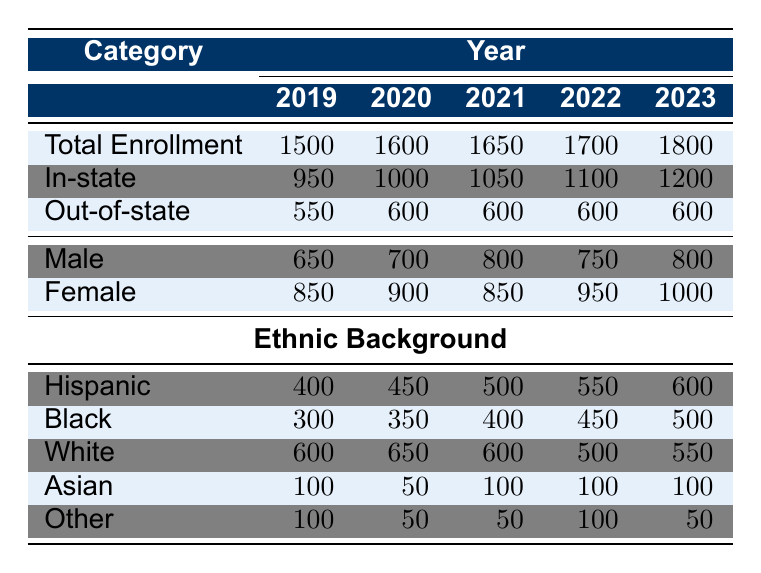What was the total enrollment of first-generation college students in 2022? The table shows that the total enrollment in 2022 is listed directly under the "Total Enrollment" row for that year, which is 1700.
Answer: 1700 How many in-state first-generation college students enrolled in 2021? The number of in-state students for 2021 is specified in the corresponding row for that year, which is 1050.
Answer: 1050 What percentage of first-generation college students in 2023 were out-of-state students? The total enrollment in 2023 is 1800, and the out-of-state students are 600. The percentage is calculated as (600/1800) * 100 = 33.33%.
Answer: 33.33% Which year had the highest total enrollment of first-generation college students? By reviewing the "Total Enrollment" row, 2023 has the highest number listed at 1800, indicating it is the year with the highest enrollment.
Answer: 2023 Were there more male or female first-generation students in 2020? In 2020, there were 700 male and 900 female students. Comparing these numbers, it's clear that there were more females.
Answer: Female What was the increase in total enrollment from 2019 to 2023? The total enrollment in 2019 was 1500 and in 2023 was 1800. The increase is calculated by subtracting 1500 from 1800, which equals 300.
Answer: 300 What is the average number of Hispanic first-generation students over the five years? The numbers for Hispanic students are 400 (2019), 450 (2020), 500 (2021), 550 (2022), and 600 (2023). Summing these gives 2500. Dividing by 5 (the number of years) gives an average of 500.
Answer: 500 In which year did the enrollment of Black first-generation students reach 450? Looking through the years in the table, the enrollment of Black students reached 450 in 2022, which is specified in the ethnic background section.
Answer: 2022 What was the ratio of male to female first-generation students in 2022? In 2022, there were 750 male and 950 female students. The ratio is calculated as 750:950, which simplifies to 15:19.
Answer: 15:19 How many first-generation students were categorized as "Other" in 2021? The row for "Other" in the ethnic background section for 2021 shows a total of 50 students listed.
Answer: 50 Did the enrollment of first-generation college students increase each year? Reviewing the total enrollment for each year from 2019 to 2023, we see a consistent increase from 1500 to 1800, indicating that enrollment did indeed increase each year.
Answer: Yes 